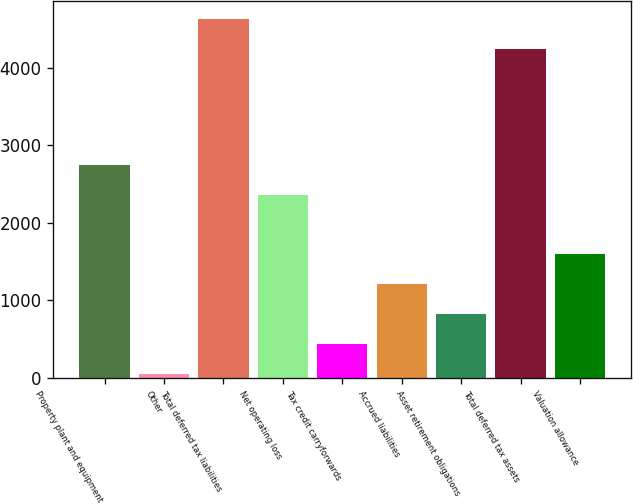Convert chart. <chart><loc_0><loc_0><loc_500><loc_500><bar_chart><fcel>Property plant and equipment<fcel>Other<fcel>Total deferred tax liabilities<fcel>Net operating loss<fcel>Tax credit carryforwards<fcel>Accrued liabilities<fcel>Asset retirement obligations<fcel>Total deferred tax assets<fcel>Valuation allowance<nl><fcel>2749.1<fcel>52<fcel>4623.6<fcel>2363.8<fcel>437.3<fcel>1207.9<fcel>822.6<fcel>4238.3<fcel>1593.2<nl></chart> 